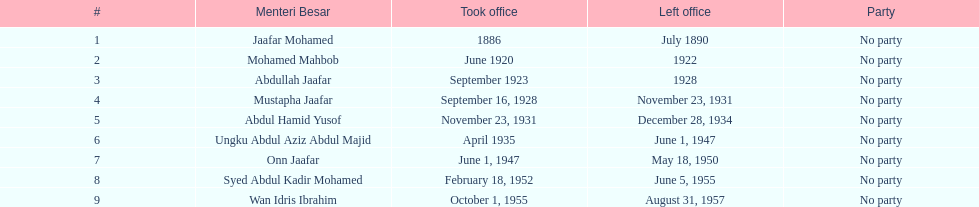How long did ungku abdul aziz abdul majid serve? 12 years. 